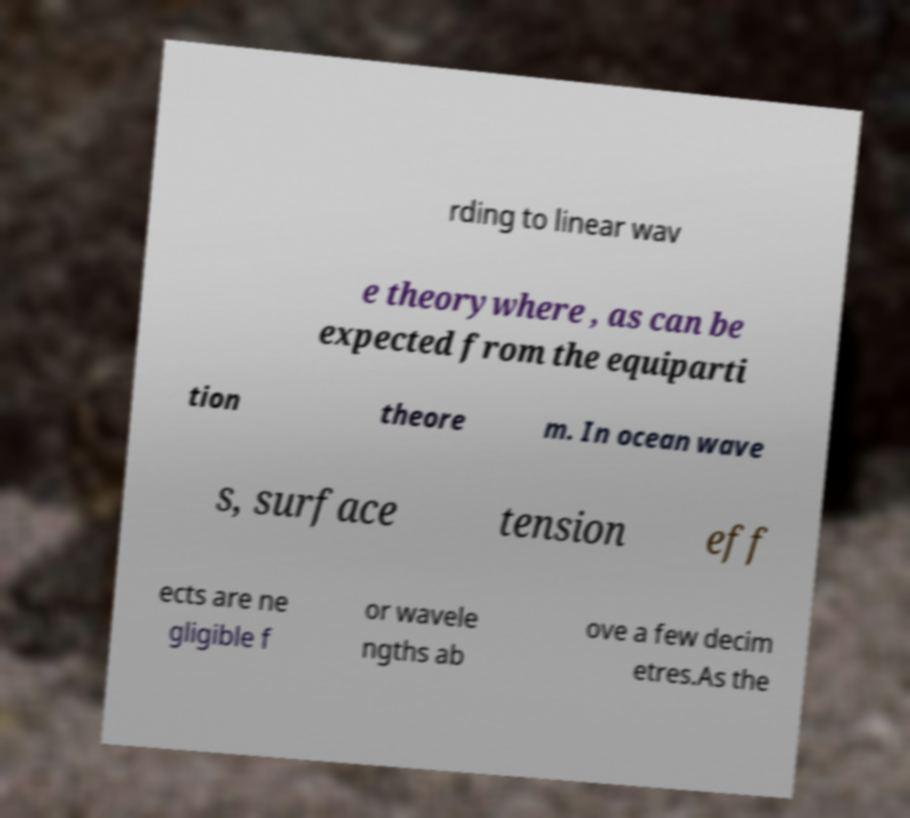Could you extract and type out the text from this image? rding to linear wav e theorywhere , as can be expected from the equiparti tion theore m. In ocean wave s, surface tension eff ects are ne gligible f or wavele ngths ab ove a few decim etres.As the 